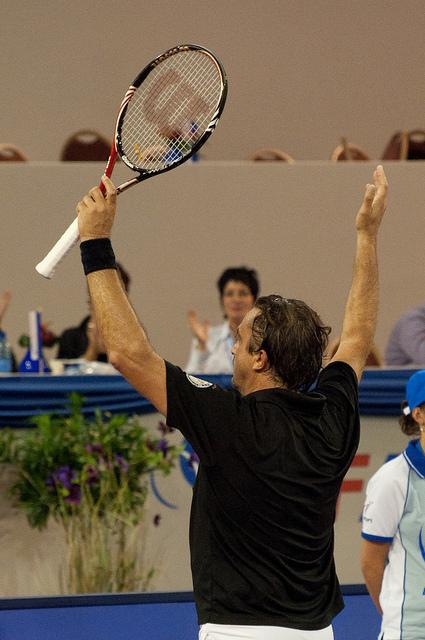Is this pictured photoshopped?
Quick response, please. No. What sport is the man playing?
Give a very brief answer. Tennis. Are there two wristbands?
Answer briefly. No. What sport is practicing the guy?
Concise answer only. Tennis. What is in the man's hand?
Be succinct. Tennis racket. Is the man old?
Concise answer only. No. What color is his shirt?
Be succinct. Black. Is there a tennis racket on the ground?
Write a very short answer. No. 